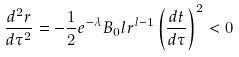Convert formula to latex. <formula><loc_0><loc_0><loc_500><loc_500>\frac { d ^ { 2 } r } { d \tau ^ { 2 } } = - \frac { 1 } { 2 } e ^ { - \lambda } B _ { 0 } l r ^ { l - 1 } \left ( \frac { d t } { d \tau } \right ) ^ { 2 } < 0</formula> 